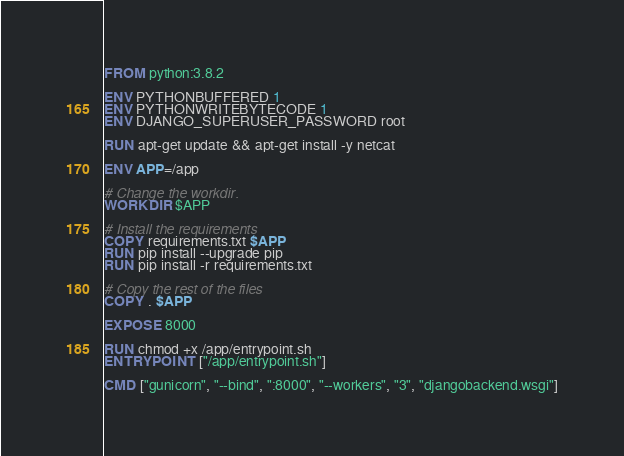Convert code to text. <code><loc_0><loc_0><loc_500><loc_500><_Dockerfile_>FROM python:3.8.2

ENV PYTHONBUFFERED 1
ENV PYTHONWRITEBYTECODE 1
ENV DJANGO_SUPERUSER_PASSWORD root

RUN apt-get update && apt-get install -y netcat

ENV APP=/app

# Change the workdir.
WORKDIR $APP

# Install the requirements
COPY requirements.txt $APP
RUN pip install --upgrade pip
RUN pip install -r requirements.txt

# Copy the rest of the files
COPY . $APP

EXPOSE 8000

RUN chmod +x /app/entrypoint.sh
ENTRYPOINT ["/app/entrypoint.sh"]

CMD ["gunicorn", "--bind", ":8000", "--workers", "3", "djangobackend.wsgi"]
</code> 